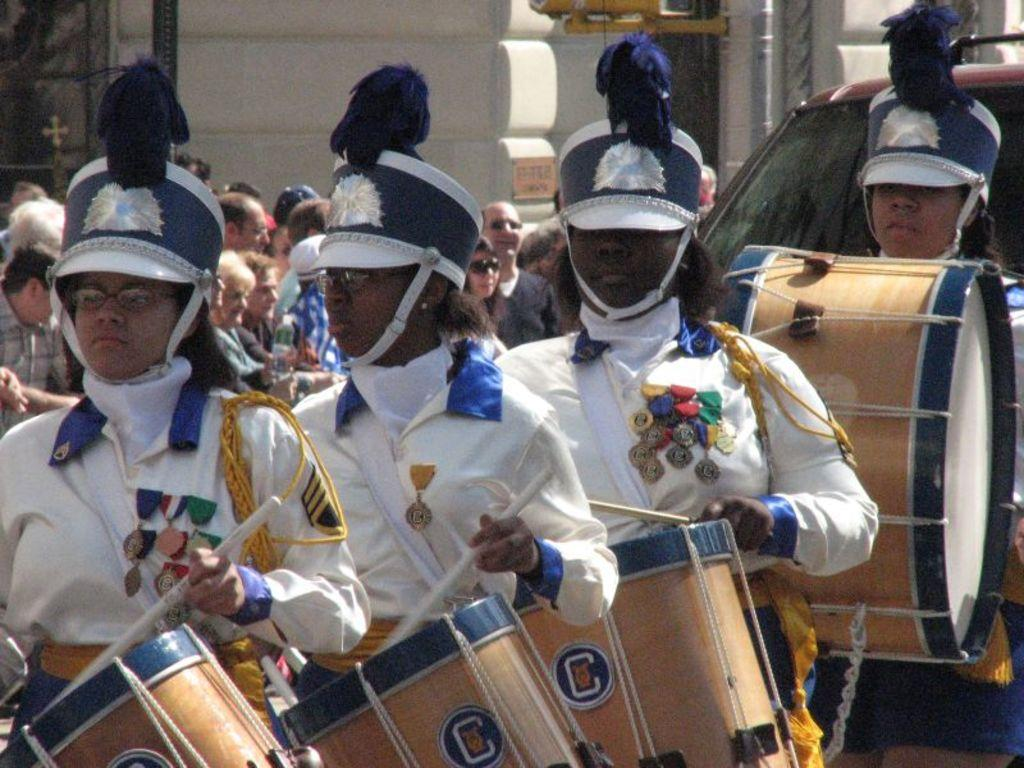How many people are in the image? There is a group of people in the image. What are some of the people in the group doing? Some people in the group are playing drums. Reasoning: Let' Let's think step by step in order to produce the conversation. We start by acknowledging the presence of a group of people in the image. Then, we focus on the specific activity that some of the people are engaged in, which is playing drums. By doing so, we provide a clear and concise description of the image based on the provided facts. Absurd Question/Answer: What type of soap is being used by the people in the image? There is no soap present in the image; the people are playing drums. Can you tell me how many tanks are visible in the image? There are no tanks visible in the image; it features a group of people playing drums. 